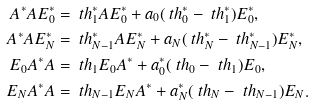<formula> <loc_0><loc_0><loc_500><loc_500>A ^ { * } A E ^ { * } _ { 0 } & = \ t h ^ { * } _ { 1 } A E ^ { * } _ { 0 } + a _ { 0 } ( \ t h ^ { * } _ { 0 } - \ t h ^ { * } _ { 1 } ) E ^ { * } _ { 0 } , \\ A ^ { * } A E ^ { * } _ { N } & = \ t h ^ { * } _ { N - 1 } A E ^ { * } _ { N } + a _ { N } ( \ t h ^ { * } _ { N } - \ t h ^ { * } _ { N - 1 } ) E ^ { * } _ { N } , \\ E _ { 0 } A ^ { * } A & = \ t h _ { 1 } E _ { 0 } A ^ { * } + a ^ { * } _ { 0 } ( \ t h _ { 0 } - \ t h _ { 1 } ) E _ { 0 } , \\ E _ { N } A ^ { * } A & = \ t h _ { N - 1 } E _ { N } A ^ { * } + a ^ { * } _ { N } ( \ t h _ { N } - \ t h _ { N - 1 } ) E _ { N } .</formula> 